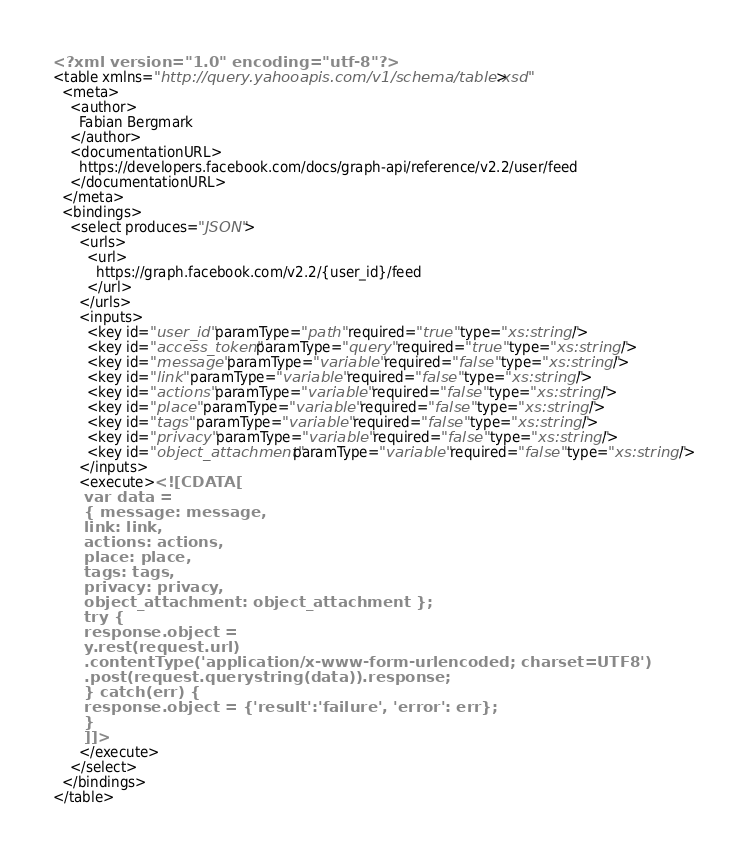Convert code to text. <code><loc_0><loc_0><loc_500><loc_500><_XML_><?xml version="1.0" encoding="utf-8"?>
<table xmlns="http://query.yahooapis.com/v1/schema/table.xsd">
  <meta>
    <author>
      Fabian Bergmark
    </author>
    <documentationURL>
      https://developers.facebook.com/docs/graph-api/reference/v2.2/user/feed
    </documentationURL>
  </meta>
  <bindings>
    <select produces="JSON">
      <urls>
        <url>
          https://graph.facebook.com/v2.2/{user_id}/feed
        </url>
      </urls>
      <inputs>
        <key id="user_id" paramType="path" required="true" type="xs:string"/>
        <key id="access_token" paramType="query" required="true" type="xs:string"/>
        <key id="message" paramType="variable" required="false" type="xs:string"/>
        <key id="link" paramType="variable" required="false" type="xs:string"/>
        <key id="actions" paramType="variable" required="false" type="xs:string"/>
        <key id="place" paramType="variable" required="false" type="xs:string"/>
        <key id="tags" paramType="variable" required="false" type="xs:string"/>
        <key id="privacy" paramType="variable" required="false" type="xs:string"/>
        <key id="object_attachment" paramType="variable" required="false" type="xs:string"/>
      </inputs>
      <execute><![CDATA[
      var data =
      { message: message,
      link: link,
      actions: actions,
      place: place,
      tags: tags,
      privacy: privacy,
      object_attachment: object_attachment };
      try {
      response.object =
      y.rest(request.url)
      .contentType('application/x-www-form-urlencoded; charset=UTF8')
      .post(request.querystring(data)).response;
      } catch(err) {
      response.object = {'result':'failure', 'error': err};
      }
      ]]>
      </execute>
    </select>
  </bindings>
</table>
</code> 